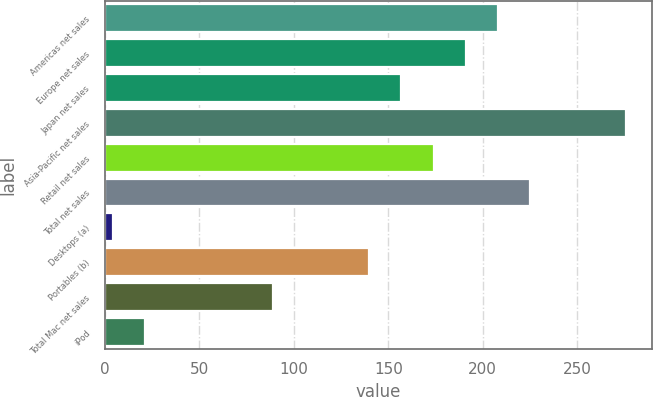<chart> <loc_0><loc_0><loc_500><loc_500><bar_chart><fcel>Americas net sales<fcel>Europe net sales<fcel>Japan net sales<fcel>Asia-Pacific net sales<fcel>Retail net sales<fcel>Total net sales<fcel>Desktops (a)<fcel>Portables (b)<fcel>Total Mac net sales<fcel>iPod<nl><fcel>208<fcel>191<fcel>157<fcel>276<fcel>174<fcel>225<fcel>4<fcel>140<fcel>89<fcel>21<nl></chart> 